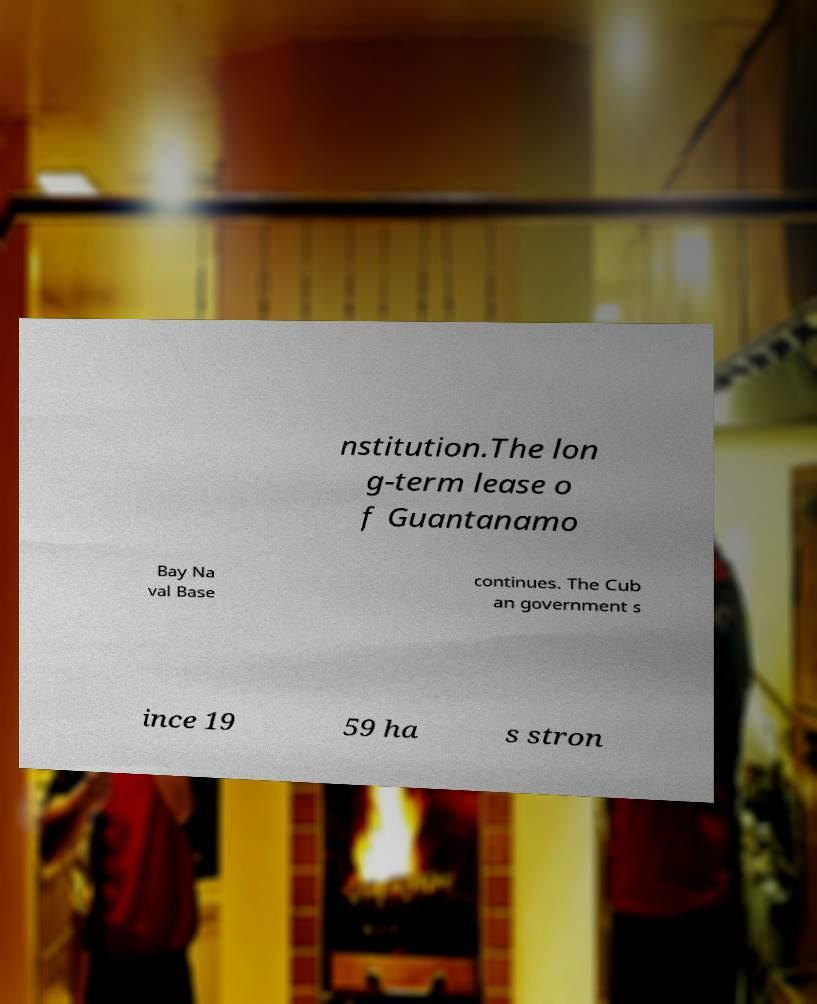Please read and relay the text visible in this image. What does it say? nstitution.The lon g-term lease o f Guantanamo Bay Na val Base continues. The Cub an government s ince 19 59 ha s stron 